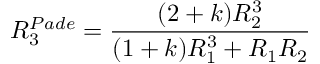<formula> <loc_0><loc_0><loc_500><loc_500>R _ { 3 } ^ { P a d e } = \frac { ( 2 + k ) R _ { 2 } ^ { 3 } } { ( 1 + k ) R _ { 1 } ^ { 3 } + R _ { 1 } R _ { 2 } }</formula> 